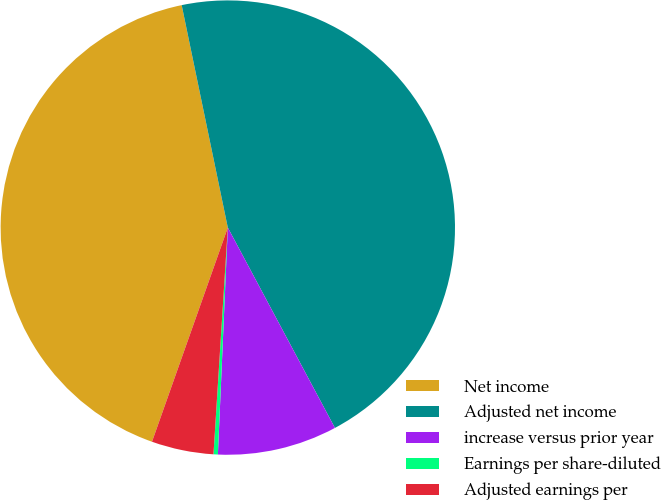<chart> <loc_0><loc_0><loc_500><loc_500><pie_chart><fcel>Net income<fcel>Adjusted net income<fcel>increase versus prior year<fcel>Earnings per share-diluted<fcel>Adjusted earnings per<nl><fcel>41.33%<fcel>45.44%<fcel>8.51%<fcel>0.31%<fcel>4.41%<nl></chart> 